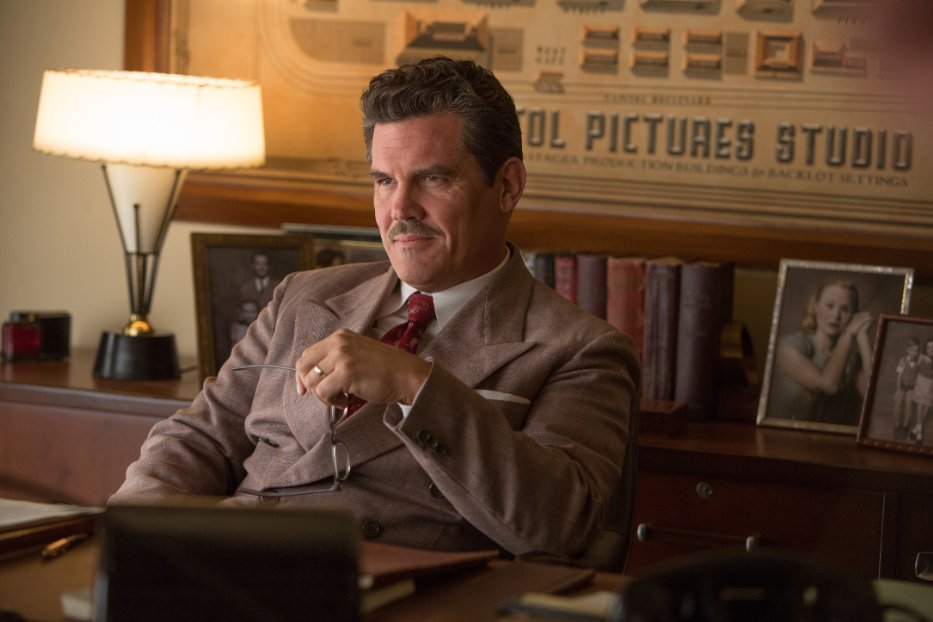Given his expression and the overall scene, what realistic challenges might Eddie Mannix be facing in his role? Eddie Mannix might be grappling with several significant challenges in his role as a studio executive. He could be dealing with a difficult decision regarding a new film project, managing a crisis involving a high-profile actor, or handling financial pressures and the competing interests of shareholders. The nature of his role likely involves constant problem-solving, balancing creative and commercial priorities, and navigating the political landscape of the film industry. 